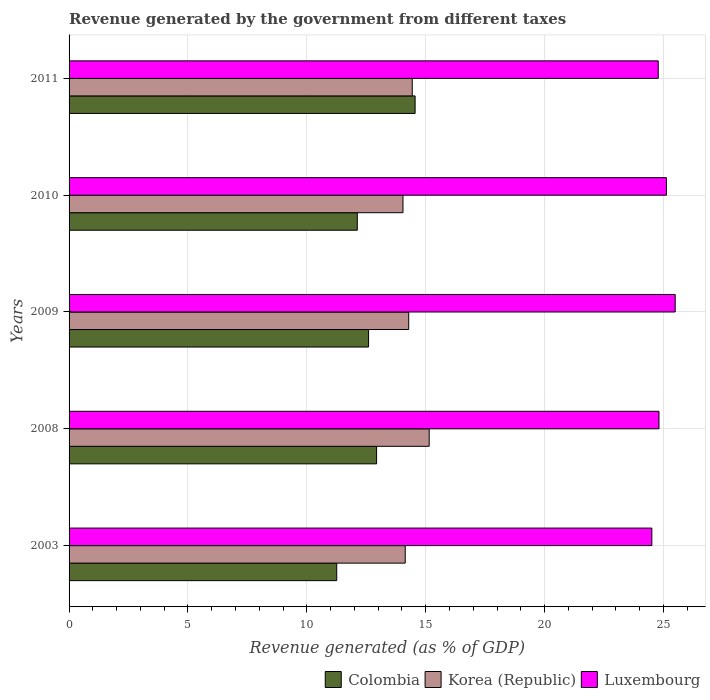How many bars are there on the 2nd tick from the top?
Make the answer very short. 3. In how many cases, is the number of bars for a given year not equal to the number of legend labels?
Your answer should be very brief. 0. What is the revenue generated by the government in Korea (Republic) in 2008?
Provide a short and direct response. 15.15. Across all years, what is the maximum revenue generated by the government in Korea (Republic)?
Offer a very short reply. 15.15. Across all years, what is the minimum revenue generated by the government in Korea (Republic)?
Ensure brevity in your answer.  14.05. In which year was the revenue generated by the government in Colombia maximum?
Your response must be concise. 2011. What is the total revenue generated by the government in Luxembourg in the graph?
Give a very brief answer. 124.73. What is the difference between the revenue generated by the government in Luxembourg in 2008 and that in 2010?
Your answer should be compact. -0.31. What is the difference between the revenue generated by the government in Luxembourg in 2010 and the revenue generated by the government in Korea (Republic) in 2003?
Offer a terse response. 10.99. What is the average revenue generated by the government in Korea (Republic) per year?
Provide a succinct answer. 14.41. In the year 2010, what is the difference between the revenue generated by the government in Colombia and revenue generated by the government in Luxembourg?
Provide a short and direct response. -13. What is the ratio of the revenue generated by the government in Luxembourg in 2009 to that in 2010?
Your response must be concise. 1.01. Is the difference between the revenue generated by the government in Colombia in 2008 and 2009 greater than the difference between the revenue generated by the government in Luxembourg in 2008 and 2009?
Keep it short and to the point. Yes. What is the difference between the highest and the second highest revenue generated by the government in Korea (Republic)?
Provide a short and direct response. 0.71. What is the difference between the highest and the lowest revenue generated by the government in Korea (Republic)?
Your answer should be very brief. 1.1. Is the sum of the revenue generated by the government in Luxembourg in 2003 and 2009 greater than the maximum revenue generated by the government in Korea (Republic) across all years?
Your response must be concise. Yes. What does the 1st bar from the top in 2003 represents?
Offer a very short reply. Luxembourg. What does the 3rd bar from the bottom in 2003 represents?
Keep it short and to the point. Luxembourg. Is it the case that in every year, the sum of the revenue generated by the government in Korea (Republic) and revenue generated by the government in Colombia is greater than the revenue generated by the government in Luxembourg?
Your answer should be compact. Yes. Does the graph contain any zero values?
Give a very brief answer. No. What is the title of the graph?
Your answer should be compact. Revenue generated by the government from different taxes. What is the label or title of the X-axis?
Make the answer very short. Revenue generated (as % of GDP). What is the Revenue generated (as % of GDP) in Colombia in 2003?
Ensure brevity in your answer.  11.26. What is the Revenue generated (as % of GDP) of Korea (Republic) in 2003?
Give a very brief answer. 14.14. What is the Revenue generated (as % of GDP) of Luxembourg in 2003?
Provide a succinct answer. 24.51. What is the Revenue generated (as % of GDP) in Colombia in 2008?
Provide a short and direct response. 12.94. What is the Revenue generated (as % of GDP) of Korea (Republic) in 2008?
Your answer should be compact. 15.15. What is the Revenue generated (as % of GDP) of Luxembourg in 2008?
Your response must be concise. 24.81. What is the Revenue generated (as % of GDP) of Colombia in 2009?
Your answer should be compact. 12.6. What is the Revenue generated (as % of GDP) of Korea (Republic) in 2009?
Your answer should be compact. 14.29. What is the Revenue generated (as % of GDP) in Luxembourg in 2009?
Provide a short and direct response. 25.5. What is the Revenue generated (as % of GDP) in Colombia in 2010?
Make the answer very short. 12.12. What is the Revenue generated (as % of GDP) in Korea (Republic) in 2010?
Ensure brevity in your answer.  14.05. What is the Revenue generated (as % of GDP) of Luxembourg in 2010?
Make the answer very short. 25.13. What is the Revenue generated (as % of GDP) of Colombia in 2011?
Provide a succinct answer. 14.56. What is the Revenue generated (as % of GDP) of Korea (Republic) in 2011?
Provide a succinct answer. 14.44. What is the Revenue generated (as % of GDP) in Luxembourg in 2011?
Your response must be concise. 24.78. Across all years, what is the maximum Revenue generated (as % of GDP) in Colombia?
Keep it short and to the point. 14.56. Across all years, what is the maximum Revenue generated (as % of GDP) in Korea (Republic)?
Your answer should be very brief. 15.15. Across all years, what is the maximum Revenue generated (as % of GDP) in Luxembourg?
Give a very brief answer. 25.5. Across all years, what is the minimum Revenue generated (as % of GDP) of Colombia?
Provide a succinct answer. 11.26. Across all years, what is the minimum Revenue generated (as % of GDP) of Korea (Republic)?
Your answer should be very brief. 14.05. Across all years, what is the minimum Revenue generated (as % of GDP) of Luxembourg?
Offer a terse response. 24.51. What is the total Revenue generated (as % of GDP) of Colombia in the graph?
Make the answer very short. 63.47. What is the total Revenue generated (as % of GDP) of Korea (Republic) in the graph?
Give a very brief answer. 72.06. What is the total Revenue generated (as % of GDP) in Luxembourg in the graph?
Provide a succinct answer. 124.73. What is the difference between the Revenue generated (as % of GDP) of Colombia in 2003 and that in 2008?
Give a very brief answer. -1.68. What is the difference between the Revenue generated (as % of GDP) in Korea (Republic) in 2003 and that in 2008?
Your answer should be very brief. -1.01. What is the difference between the Revenue generated (as % of GDP) in Luxembourg in 2003 and that in 2008?
Ensure brevity in your answer.  -0.3. What is the difference between the Revenue generated (as % of GDP) of Colombia in 2003 and that in 2009?
Offer a terse response. -1.34. What is the difference between the Revenue generated (as % of GDP) in Korea (Republic) in 2003 and that in 2009?
Your answer should be compact. -0.15. What is the difference between the Revenue generated (as % of GDP) of Luxembourg in 2003 and that in 2009?
Provide a succinct answer. -0.98. What is the difference between the Revenue generated (as % of GDP) in Colombia in 2003 and that in 2010?
Ensure brevity in your answer.  -0.86. What is the difference between the Revenue generated (as % of GDP) in Korea (Republic) in 2003 and that in 2010?
Your answer should be compact. 0.09. What is the difference between the Revenue generated (as % of GDP) of Luxembourg in 2003 and that in 2010?
Provide a short and direct response. -0.61. What is the difference between the Revenue generated (as % of GDP) of Colombia in 2003 and that in 2011?
Offer a terse response. -3.3. What is the difference between the Revenue generated (as % of GDP) in Korea (Republic) in 2003 and that in 2011?
Keep it short and to the point. -0.3. What is the difference between the Revenue generated (as % of GDP) of Luxembourg in 2003 and that in 2011?
Your answer should be very brief. -0.27. What is the difference between the Revenue generated (as % of GDP) in Colombia in 2008 and that in 2009?
Offer a very short reply. 0.34. What is the difference between the Revenue generated (as % of GDP) of Korea (Republic) in 2008 and that in 2009?
Your answer should be compact. 0.86. What is the difference between the Revenue generated (as % of GDP) in Luxembourg in 2008 and that in 2009?
Make the answer very short. -0.68. What is the difference between the Revenue generated (as % of GDP) of Colombia in 2008 and that in 2010?
Keep it short and to the point. 0.81. What is the difference between the Revenue generated (as % of GDP) of Korea (Republic) in 2008 and that in 2010?
Offer a very short reply. 1.1. What is the difference between the Revenue generated (as % of GDP) in Luxembourg in 2008 and that in 2010?
Keep it short and to the point. -0.31. What is the difference between the Revenue generated (as % of GDP) of Colombia in 2008 and that in 2011?
Offer a very short reply. -1.62. What is the difference between the Revenue generated (as % of GDP) in Korea (Republic) in 2008 and that in 2011?
Make the answer very short. 0.71. What is the difference between the Revenue generated (as % of GDP) in Luxembourg in 2008 and that in 2011?
Give a very brief answer. 0.03. What is the difference between the Revenue generated (as % of GDP) of Colombia in 2009 and that in 2010?
Your answer should be compact. 0.48. What is the difference between the Revenue generated (as % of GDP) in Korea (Republic) in 2009 and that in 2010?
Offer a terse response. 0.24. What is the difference between the Revenue generated (as % of GDP) of Luxembourg in 2009 and that in 2010?
Keep it short and to the point. 0.37. What is the difference between the Revenue generated (as % of GDP) in Colombia in 2009 and that in 2011?
Offer a terse response. -1.96. What is the difference between the Revenue generated (as % of GDP) in Korea (Republic) in 2009 and that in 2011?
Offer a terse response. -0.15. What is the difference between the Revenue generated (as % of GDP) of Luxembourg in 2009 and that in 2011?
Your answer should be very brief. 0.71. What is the difference between the Revenue generated (as % of GDP) in Colombia in 2010 and that in 2011?
Ensure brevity in your answer.  -2.43. What is the difference between the Revenue generated (as % of GDP) in Korea (Republic) in 2010 and that in 2011?
Make the answer very short. -0.39. What is the difference between the Revenue generated (as % of GDP) in Luxembourg in 2010 and that in 2011?
Provide a succinct answer. 0.34. What is the difference between the Revenue generated (as % of GDP) of Colombia in 2003 and the Revenue generated (as % of GDP) of Korea (Republic) in 2008?
Ensure brevity in your answer.  -3.89. What is the difference between the Revenue generated (as % of GDP) in Colombia in 2003 and the Revenue generated (as % of GDP) in Luxembourg in 2008?
Keep it short and to the point. -13.56. What is the difference between the Revenue generated (as % of GDP) in Korea (Republic) in 2003 and the Revenue generated (as % of GDP) in Luxembourg in 2008?
Keep it short and to the point. -10.67. What is the difference between the Revenue generated (as % of GDP) of Colombia in 2003 and the Revenue generated (as % of GDP) of Korea (Republic) in 2009?
Provide a short and direct response. -3.03. What is the difference between the Revenue generated (as % of GDP) in Colombia in 2003 and the Revenue generated (as % of GDP) in Luxembourg in 2009?
Your answer should be compact. -14.24. What is the difference between the Revenue generated (as % of GDP) in Korea (Republic) in 2003 and the Revenue generated (as % of GDP) in Luxembourg in 2009?
Keep it short and to the point. -11.36. What is the difference between the Revenue generated (as % of GDP) in Colombia in 2003 and the Revenue generated (as % of GDP) in Korea (Republic) in 2010?
Offer a terse response. -2.79. What is the difference between the Revenue generated (as % of GDP) of Colombia in 2003 and the Revenue generated (as % of GDP) of Luxembourg in 2010?
Make the answer very short. -13.87. What is the difference between the Revenue generated (as % of GDP) in Korea (Republic) in 2003 and the Revenue generated (as % of GDP) in Luxembourg in 2010?
Make the answer very short. -10.99. What is the difference between the Revenue generated (as % of GDP) of Colombia in 2003 and the Revenue generated (as % of GDP) of Korea (Republic) in 2011?
Ensure brevity in your answer.  -3.18. What is the difference between the Revenue generated (as % of GDP) in Colombia in 2003 and the Revenue generated (as % of GDP) in Luxembourg in 2011?
Keep it short and to the point. -13.52. What is the difference between the Revenue generated (as % of GDP) of Korea (Republic) in 2003 and the Revenue generated (as % of GDP) of Luxembourg in 2011?
Offer a very short reply. -10.64. What is the difference between the Revenue generated (as % of GDP) in Colombia in 2008 and the Revenue generated (as % of GDP) in Korea (Republic) in 2009?
Make the answer very short. -1.35. What is the difference between the Revenue generated (as % of GDP) of Colombia in 2008 and the Revenue generated (as % of GDP) of Luxembourg in 2009?
Ensure brevity in your answer.  -12.56. What is the difference between the Revenue generated (as % of GDP) in Korea (Republic) in 2008 and the Revenue generated (as % of GDP) in Luxembourg in 2009?
Ensure brevity in your answer.  -10.35. What is the difference between the Revenue generated (as % of GDP) in Colombia in 2008 and the Revenue generated (as % of GDP) in Korea (Republic) in 2010?
Provide a short and direct response. -1.11. What is the difference between the Revenue generated (as % of GDP) in Colombia in 2008 and the Revenue generated (as % of GDP) in Luxembourg in 2010?
Your answer should be compact. -12.19. What is the difference between the Revenue generated (as % of GDP) of Korea (Republic) in 2008 and the Revenue generated (as % of GDP) of Luxembourg in 2010?
Offer a terse response. -9.98. What is the difference between the Revenue generated (as % of GDP) in Colombia in 2008 and the Revenue generated (as % of GDP) in Luxembourg in 2011?
Give a very brief answer. -11.85. What is the difference between the Revenue generated (as % of GDP) of Korea (Republic) in 2008 and the Revenue generated (as % of GDP) of Luxembourg in 2011?
Provide a succinct answer. -9.63. What is the difference between the Revenue generated (as % of GDP) in Colombia in 2009 and the Revenue generated (as % of GDP) in Korea (Republic) in 2010?
Your response must be concise. -1.45. What is the difference between the Revenue generated (as % of GDP) of Colombia in 2009 and the Revenue generated (as % of GDP) of Luxembourg in 2010?
Your answer should be compact. -12.53. What is the difference between the Revenue generated (as % of GDP) of Korea (Republic) in 2009 and the Revenue generated (as % of GDP) of Luxembourg in 2010?
Provide a short and direct response. -10.84. What is the difference between the Revenue generated (as % of GDP) of Colombia in 2009 and the Revenue generated (as % of GDP) of Korea (Republic) in 2011?
Your answer should be very brief. -1.84. What is the difference between the Revenue generated (as % of GDP) of Colombia in 2009 and the Revenue generated (as % of GDP) of Luxembourg in 2011?
Your response must be concise. -12.18. What is the difference between the Revenue generated (as % of GDP) of Korea (Republic) in 2009 and the Revenue generated (as % of GDP) of Luxembourg in 2011?
Your answer should be compact. -10.5. What is the difference between the Revenue generated (as % of GDP) in Colombia in 2010 and the Revenue generated (as % of GDP) in Korea (Republic) in 2011?
Your response must be concise. -2.31. What is the difference between the Revenue generated (as % of GDP) in Colombia in 2010 and the Revenue generated (as % of GDP) in Luxembourg in 2011?
Your answer should be compact. -12.66. What is the difference between the Revenue generated (as % of GDP) in Korea (Republic) in 2010 and the Revenue generated (as % of GDP) in Luxembourg in 2011?
Offer a very short reply. -10.74. What is the average Revenue generated (as % of GDP) in Colombia per year?
Keep it short and to the point. 12.69. What is the average Revenue generated (as % of GDP) in Korea (Republic) per year?
Your response must be concise. 14.41. What is the average Revenue generated (as % of GDP) in Luxembourg per year?
Offer a terse response. 24.95. In the year 2003, what is the difference between the Revenue generated (as % of GDP) in Colombia and Revenue generated (as % of GDP) in Korea (Republic)?
Offer a terse response. -2.88. In the year 2003, what is the difference between the Revenue generated (as % of GDP) of Colombia and Revenue generated (as % of GDP) of Luxembourg?
Offer a very short reply. -13.26. In the year 2003, what is the difference between the Revenue generated (as % of GDP) in Korea (Republic) and Revenue generated (as % of GDP) in Luxembourg?
Make the answer very short. -10.37. In the year 2008, what is the difference between the Revenue generated (as % of GDP) in Colombia and Revenue generated (as % of GDP) in Korea (Republic)?
Give a very brief answer. -2.21. In the year 2008, what is the difference between the Revenue generated (as % of GDP) in Colombia and Revenue generated (as % of GDP) in Luxembourg?
Provide a short and direct response. -11.88. In the year 2008, what is the difference between the Revenue generated (as % of GDP) of Korea (Republic) and Revenue generated (as % of GDP) of Luxembourg?
Provide a succinct answer. -9.67. In the year 2009, what is the difference between the Revenue generated (as % of GDP) in Colombia and Revenue generated (as % of GDP) in Korea (Republic)?
Provide a succinct answer. -1.69. In the year 2009, what is the difference between the Revenue generated (as % of GDP) in Colombia and Revenue generated (as % of GDP) in Luxembourg?
Provide a short and direct response. -12.9. In the year 2009, what is the difference between the Revenue generated (as % of GDP) in Korea (Republic) and Revenue generated (as % of GDP) in Luxembourg?
Your response must be concise. -11.21. In the year 2010, what is the difference between the Revenue generated (as % of GDP) of Colombia and Revenue generated (as % of GDP) of Korea (Republic)?
Offer a very short reply. -1.92. In the year 2010, what is the difference between the Revenue generated (as % of GDP) of Colombia and Revenue generated (as % of GDP) of Luxembourg?
Your answer should be compact. -13. In the year 2010, what is the difference between the Revenue generated (as % of GDP) of Korea (Republic) and Revenue generated (as % of GDP) of Luxembourg?
Keep it short and to the point. -11.08. In the year 2011, what is the difference between the Revenue generated (as % of GDP) in Colombia and Revenue generated (as % of GDP) in Korea (Republic)?
Your answer should be very brief. 0.12. In the year 2011, what is the difference between the Revenue generated (as % of GDP) of Colombia and Revenue generated (as % of GDP) of Luxembourg?
Your answer should be very brief. -10.23. In the year 2011, what is the difference between the Revenue generated (as % of GDP) in Korea (Republic) and Revenue generated (as % of GDP) in Luxembourg?
Offer a terse response. -10.35. What is the ratio of the Revenue generated (as % of GDP) of Colombia in 2003 to that in 2008?
Offer a very short reply. 0.87. What is the ratio of the Revenue generated (as % of GDP) of Korea (Republic) in 2003 to that in 2008?
Your answer should be compact. 0.93. What is the ratio of the Revenue generated (as % of GDP) in Luxembourg in 2003 to that in 2008?
Your response must be concise. 0.99. What is the ratio of the Revenue generated (as % of GDP) in Colombia in 2003 to that in 2009?
Provide a short and direct response. 0.89. What is the ratio of the Revenue generated (as % of GDP) in Luxembourg in 2003 to that in 2009?
Your answer should be compact. 0.96. What is the ratio of the Revenue generated (as % of GDP) of Colombia in 2003 to that in 2010?
Make the answer very short. 0.93. What is the ratio of the Revenue generated (as % of GDP) in Korea (Republic) in 2003 to that in 2010?
Make the answer very short. 1.01. What is the ratio of the Revenue generated (as % of GDP) in Luxembourg in 2003 to that in 2010?
Provide a short and direct response. 0.98. What is the ratio of the Revenue generated (as % of GDP) in Colombia in 2003 to that in 2011?
Your answer should be compact. 0.77. What is the ratio of the Revenue generated (as % of GDP) of Korea (Republic) in 2003 to that in 2011?
Your response must be concise. 0.98. What is the ratio of the Revenue generated (as % of GDP) in Luxembourg in 2003 to that in 2011?
Ensure brevity in your answer.  0.99. What is the ratio of the Revenue generated (as % of GDP) of Colombia in 2008 to that in 2009?
Give a very brief answer. 1.03. What is the ratio of the Revenue generated (as % of GDP) in Korea (Republic) in 2008 to that in 2009?
Offer a very short reply. 1.06. What is the ratio of the Revenue generated (as % of GDP) in Luxembourg in 2008 to that in 2009?
Provide a short and direct response. 0.97. What is the ratio of the Revenue generated (as % of GDP) of Colombia in 2008 to that in 2010?
Your answer should be very brief. 1.07. What is the ratio of the Revenue generated (as % of GDP) in Korea (Republic) in 2008 to that in 2010?
Provide a short and direct response. 1.08. What is the ratio of the Revenue generated (as % of GDP) of Luxembourg in 2008 to that in 2010?
Offer a very short reply. 0.99. What is the ratio of the Revenue generated (as % of GDP) in Colombia in 2008 to that in 2011?
Your response must be concise. 0.89. What is the ratio of the Revenue generated (as % of GDP) of Korea (Republic) in 2008 to that in 2011?
Your answer should be very brief. 1.05. What is the ratio of the Revenue generated (as % of GDP) of Luxembourg in 2008 to that in 2011?
Ensure brevity in your answer.  1. What is the ratio of the Revenue generated (as % of GDP) of Colombia in 2009 to that in 2010?
Provide a succinct answer. 1.04. What is the ratio of the Revenue generated (as % of GDP) of Korea (Republic) in 2009 to that in 2010?
Your answer should be compact. 1.02. What is the ratio of the Revenue generated (as % of GDP) of Luxembourg in 2009 to that in 2010?
Offer a terse response. 1.01. What is the ratio of the Revenue generated (as % of GDP) of Colombia in 2009 to that in 2011?
Your answer should be very brief. 0.87. What is the ratio of the Revenue generated (as % of GDP) of Korea (Republic) in 2009 to that in 2011?
Ensure brevity in your answer.  0.99. What is the ratio of the Revenue generated (as % of GDP) in Luxembourg in 2009 to that in 2011?
Give a very brief answer. 1.03. What is the ratio of the Revenue generated (as % of GDP) of Colombia in 2010 to that in 2011?
Provide a succinct answer. 0.83. What is the ratio of the Revenue generated (as % of GDP) of Korea (Republic) in 2010 to that in 2011?
Give a very brief answer. 0.97. What is the ratio of the Revenue generated (as % of GDP) in Luxembourg in 2010 to that in 2011?
Provide a short and direct response. 1.01. What is the difference between the highest and the second highest Revenue generated (as % of GDP) of Colombia?
Provide a short and direct response. 1.62. What is the difference between the highest and the second highest Revenue generated (as % of GDP) in Korea (Republic)?
Your answer should be very brief. 0.71. What is the difference between the highest and the second highest Revenue generated (as % of GDP) of Luxembourg?
Provide a succinct answer. 0.37. What is the difference between the highest and the lowest Revenue generated (as % of GDP) in Colombia?
Give a very brief answer. 3.3. What is the difference between the highest and the lowest Revenue generated (as % of GDP) of Korea (Republic)?
Ensure brevity in your answer.  1.1. What is the difference between the highest and the lowest Revenue generated (as % of GDP) in Luxembourg?
Offer a very short reply. 0.98. 